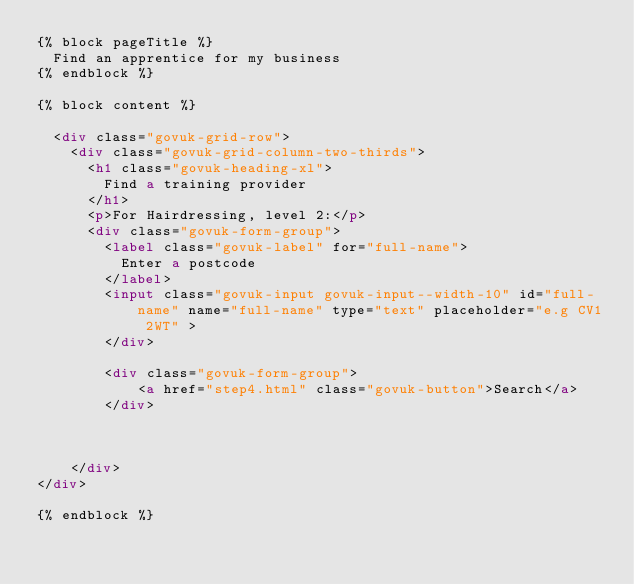Convert code to text. <code><loc_0><loc_0><loc_500><loc_500><_HTML_>{% block pageTitle %}
  Find an apprentice for my business
{% endblock %}

{% block content %}

  <div class="govuk-grid-row">
    <div class="govuk-grid-column-two-thirds">
      <h1 class="govuk-heading-xl">
        Find a training provider
      </h1>
      <p>For Hairdressing, level 2:</p>
      <div class="govuk-form-group">
        <label class="govuk-label" for="full-name">
          Enter a postcode
        </label>
        <input class="govuk-input govuk-input--width-10" id="full-name" name="full-name" type="text" placeholder="e.g CV1 2WT" >
        </div>

        <div class="govuk-form-group">
            <a href="step4.html" class="govuk-button">Search</a>
        </div>



    </div>
</div>

{% endblock %}
</code> 